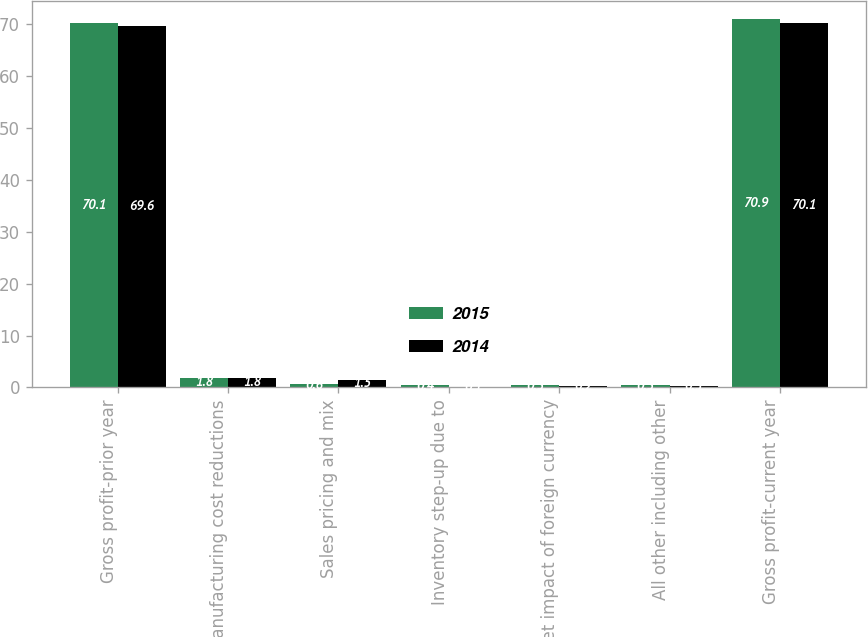Convert chart to OTSL. <chart><loc_0><loc_0><loc_500><loc_500><stacked_bar_chart><ecel><fcel>Gross profit-prior year<fcel>Manufacturing cost reductions<fcel>Sales pricing and mix<fcel>Inventory step-up due to<fcel>Net impact of foreign currency<fcel>All other including other<fcel>Gross profit-current year<nl><fcel>2015<fcel>70.1<fcel>1.8<fcel>0.6<fcel>0.4<fcel>0.5<fcel>0.5<fcel>70.9<nl><fcel>2014<fcel>69.6<fcel>1.8<fcel>1.5<fcel>0.1<fcel>0.2<fcel>0.3<fcel>70.1<nl></chart> 